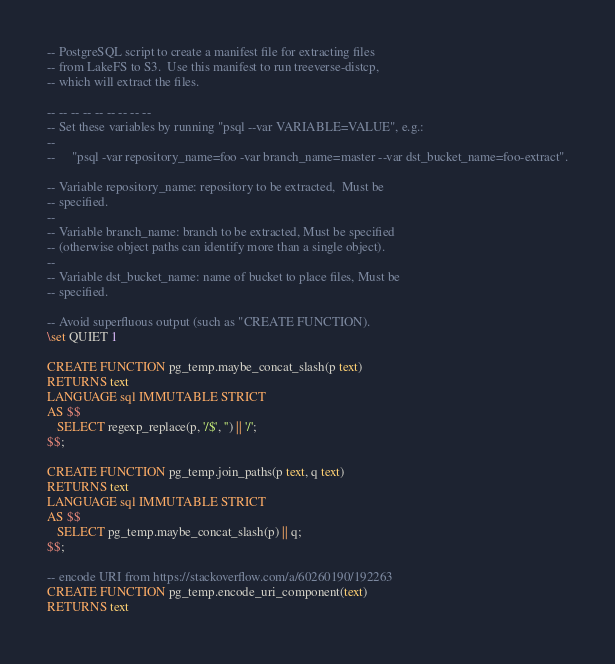<code> <loc_0><loc_0><loc_500><loc_500><_SQL_>-- PostgreSQL script to create a manifest file for extracting files
-- from LakeFS to S3.  Use this manifest to run treeverse-distcp,
-- which will extract the files.

-- -- -- -- -- -- -- -- --
-- Set these variables by running "psql --var VARIABLE=VALUE", e.g.:
--
--     "psql -var repository_name=foo -var branch_name=master --var dst_bucket_name=foo-extract".

-- Variable repository_name: repository to be extracted,  Must be
-- specified.
--
-- Variable branch_name: branch to be extracted, Must be specified
-- (otherwise object paths can identify more than a single object).
--
-- Variable dst_bucket_name: name of bucket to place files, Must be
-- specified.

-- Avoid superfluous output (such as "CREATE FUNCTION).
\set QUIET 1

CREATE FUNCTION pg_temp.maybe_concat_slash(p text)
RETURNS text
LANGUAGE sql IMMUTABLE STRICT
AS $$
   SELECT regexp_replace(p, '/$', '') || '/';
$$;

CREATE FUNCTION pg_temp.join_paths(p text, q text)
RETURNS text
LANGUAGE sql IMMUTABLE STRICT
AS $$
   SELECT pg_temp.maybe_concat_slash(p) || q;
$$;

-- encode URI from https://stackoverflow.com/a/60260190/192263
CREATE FUNCTION pg_temp.encode_uri_component(text)
RETURNS text</code> 